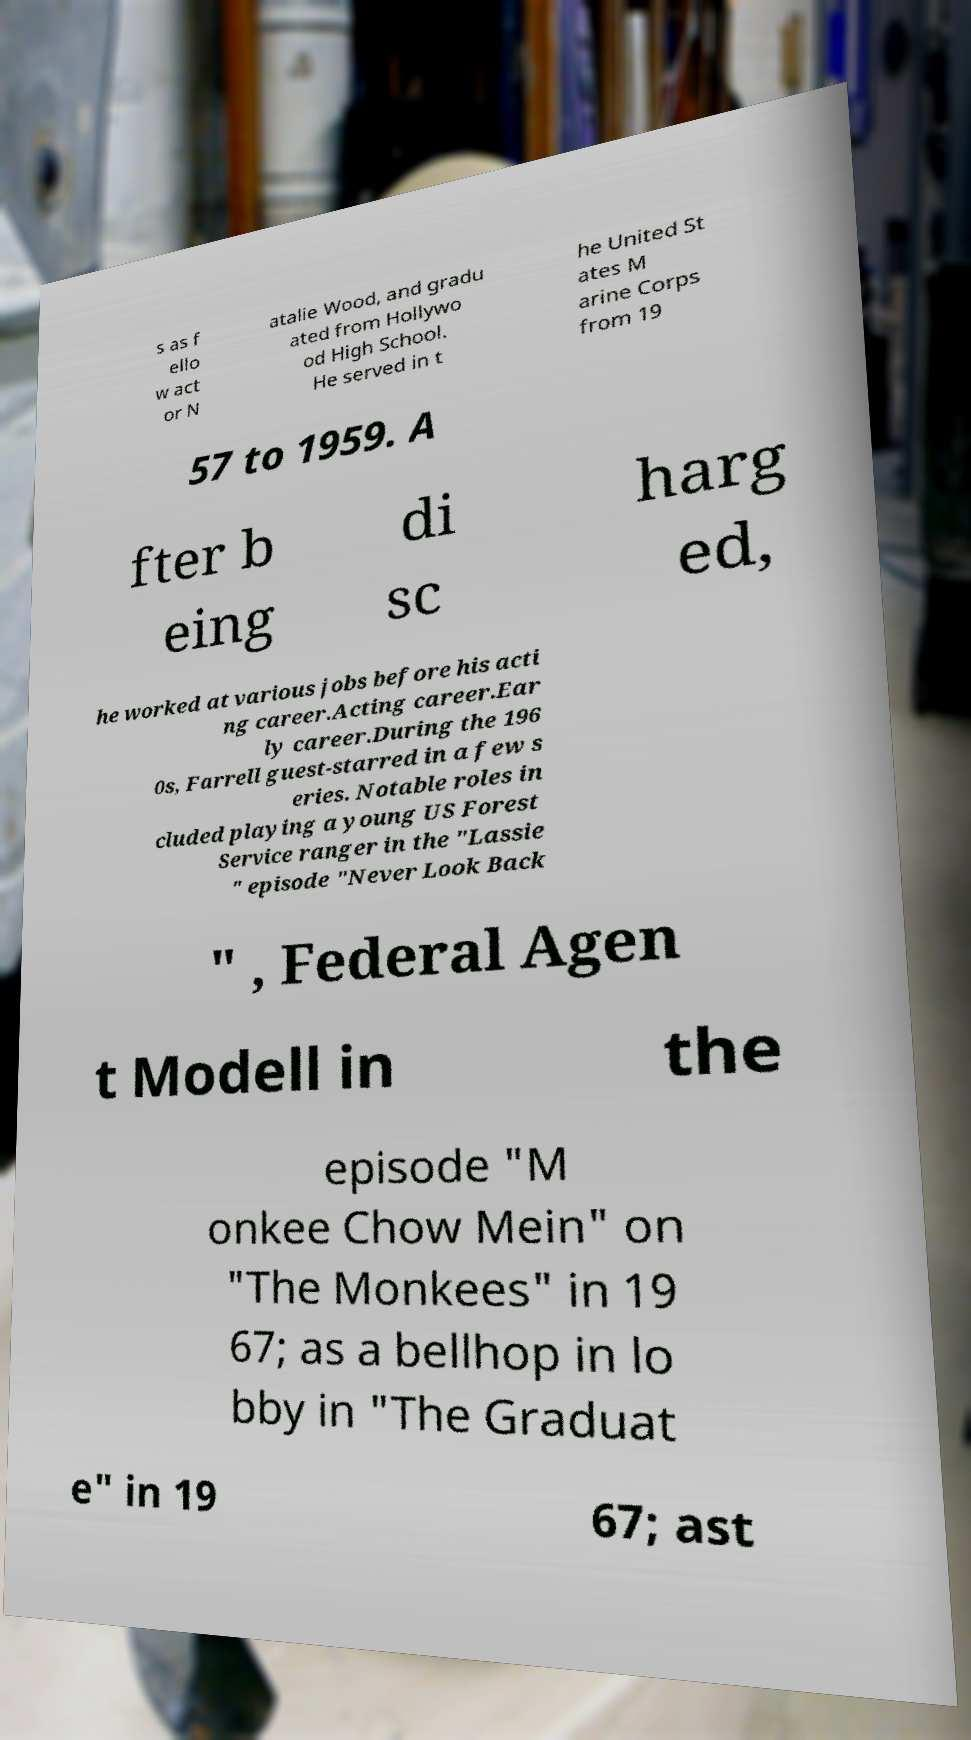Please read and relay the text visible in this image. What does it say? s as f ello w act or N atalie Wood, and gradu ated from Hollywo od High School. He served in t he United St ates M arine Corps from 19 57 to 1959. A fter b eing di sc harg ed, he worked at various jobs before his acti ng career.Acting career.Ear ly career.During the 196 0s, Farrell guest-starred in a few s eries. Notable roles in cluded playing a young US Forest Service ranger in the "Lassie " episode "Never Look Back " , Federal Agen t Modell in the episode "M onkee Chow Mein" on "The Monkees" in 19 67; as a bellhop in lo bby in "The Graduat e" in 19 67; ast 